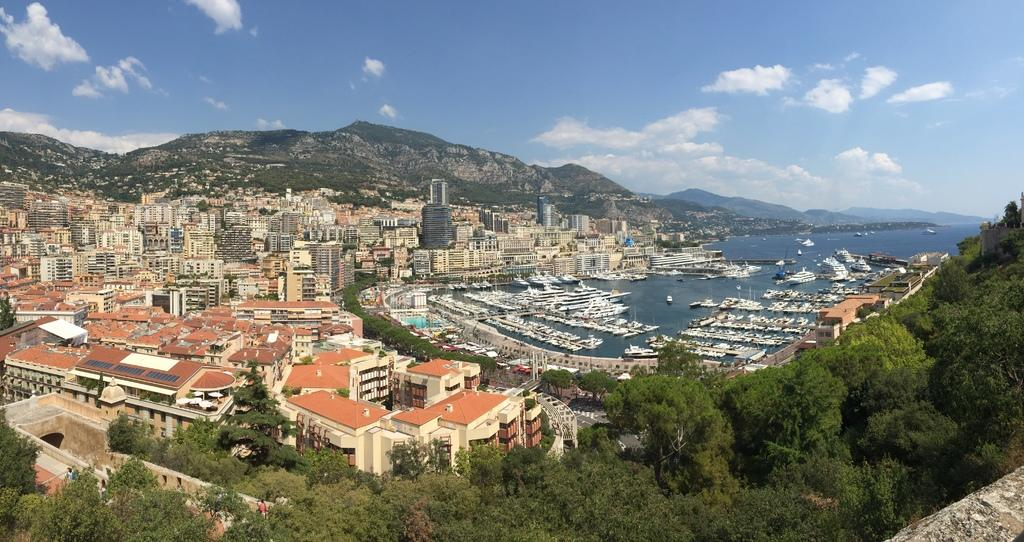What type of structures are present in the image? There are buildings with windows in the image. What natural features can be seen in the image? There are mountains and trees in the image. What is visible in the background of the image? The sky is visible in the background of the image. Can you see any toes or wounds on the buildings in the image? There are no toes or wounds present on the buildings in the image; it features structures with windows, mountains, trees, and the sky. Is there a cannon visible in the image? There is no cannon present in the image. 